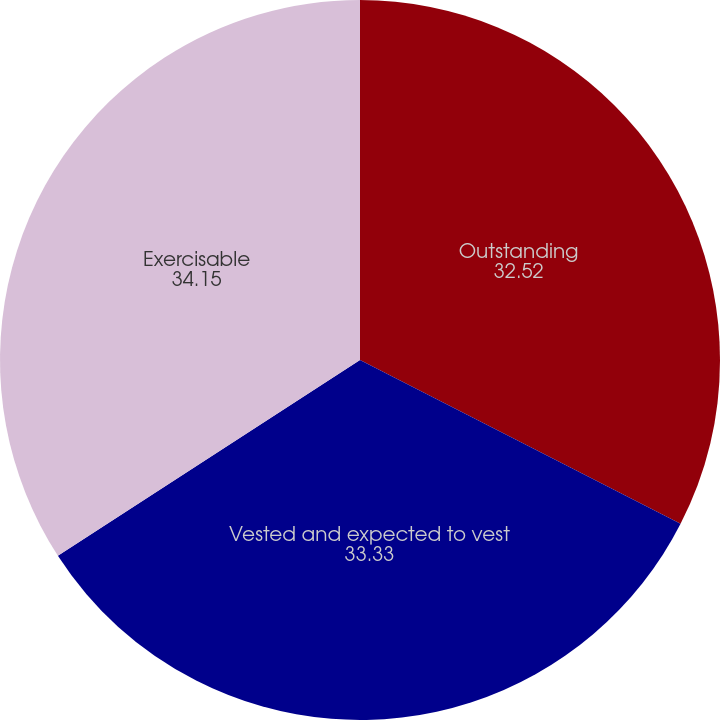<chart> <loc_0><loc_0><loc_500><loc_500><pie_chart><fcel>Outstanding<fcel>Vested and expected to vest<fcel>Exercisable<nl><fcel>32.52%<fcel>33.33%<fcel>34.15%<nl></chart> 